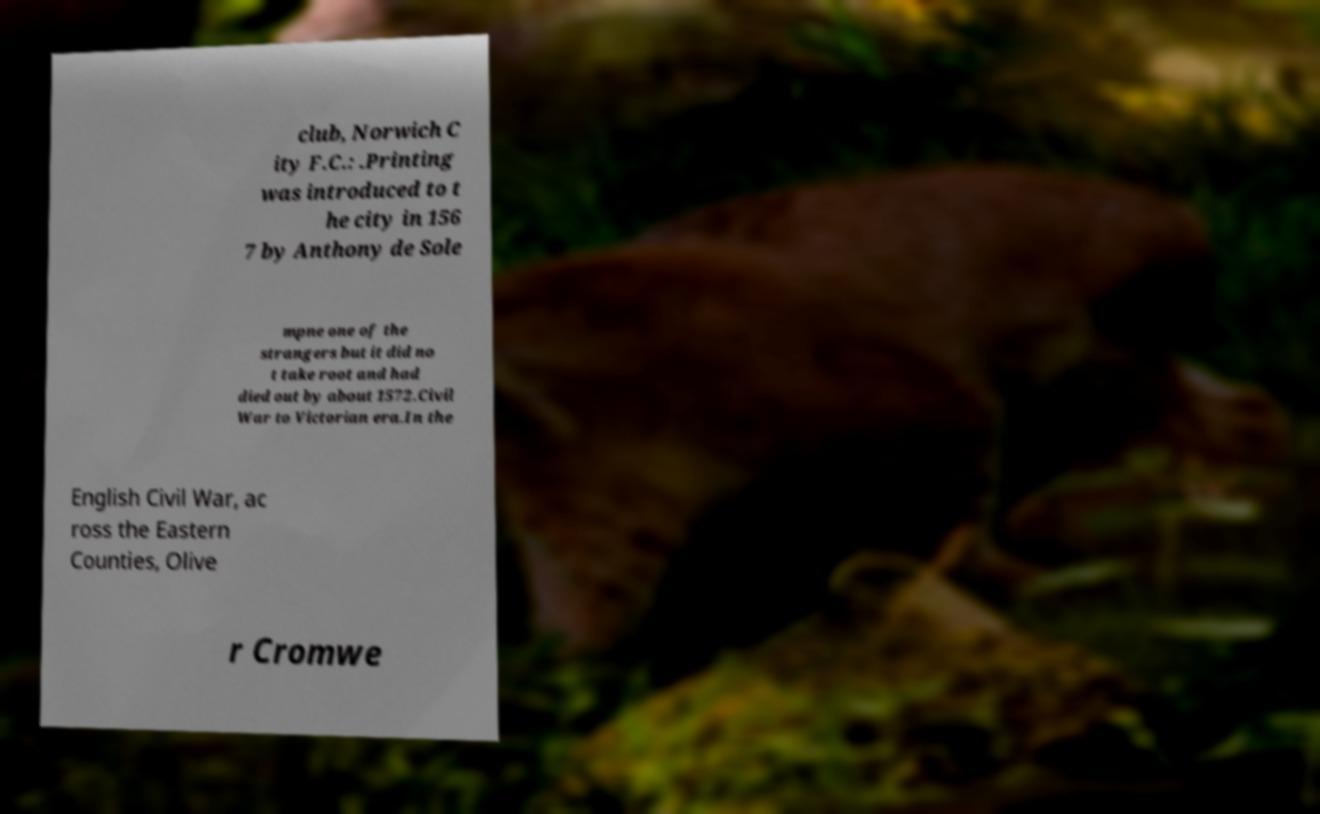Please identify and transcribe the text found in this image. club, Norwich C ity F.C.: .Printing was introduced to t he city in 156 7 by Anthony de Sole mpne one of the strangers but it did no t take root and had died out by about 1572.Civil War to Victorian era.In the English Civil War, ac ross the Eastern Counties, Olive r Cromwe 